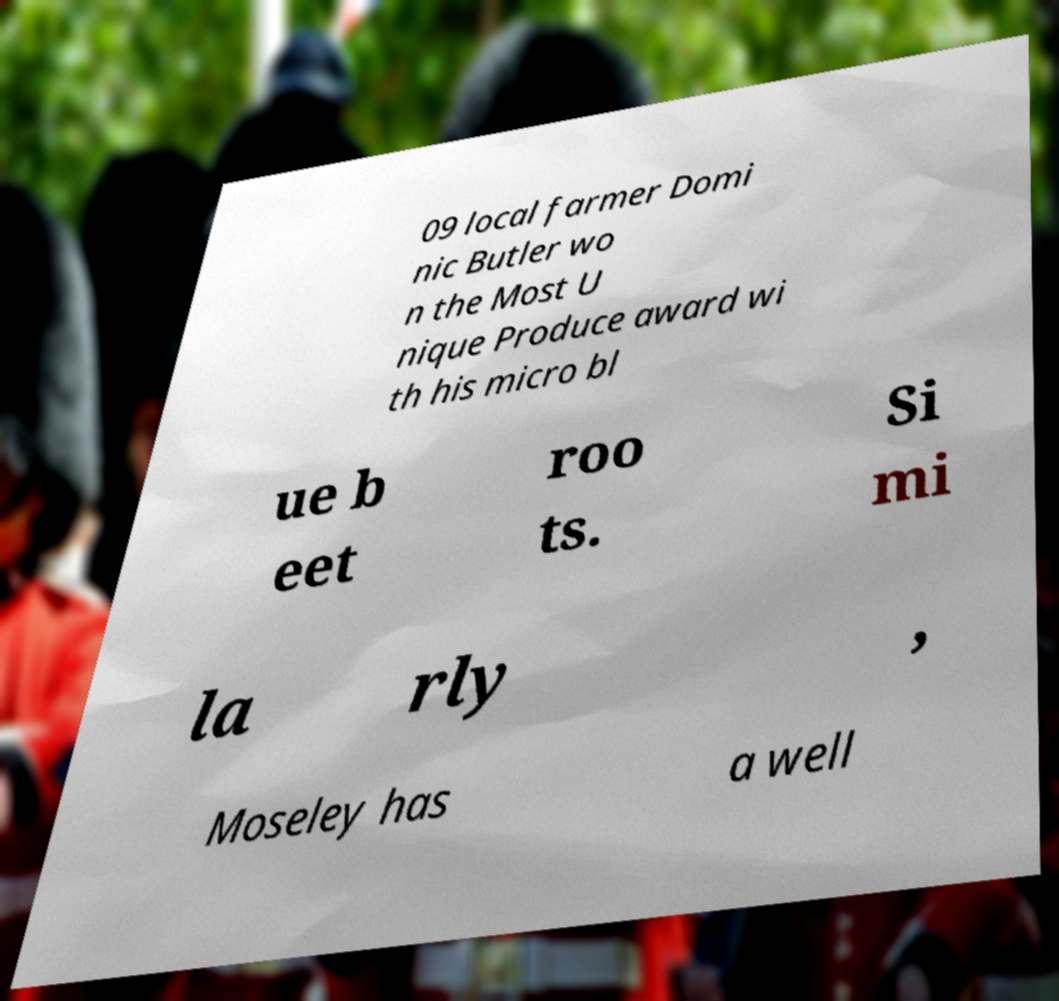Please identify and transcribe the text found in this image. 09 local farmer Domi nic Butler wo n the Most U nique Produce award wi th his micro bl ue b eet roo ts. Si mi la rly , Moseley has a well 